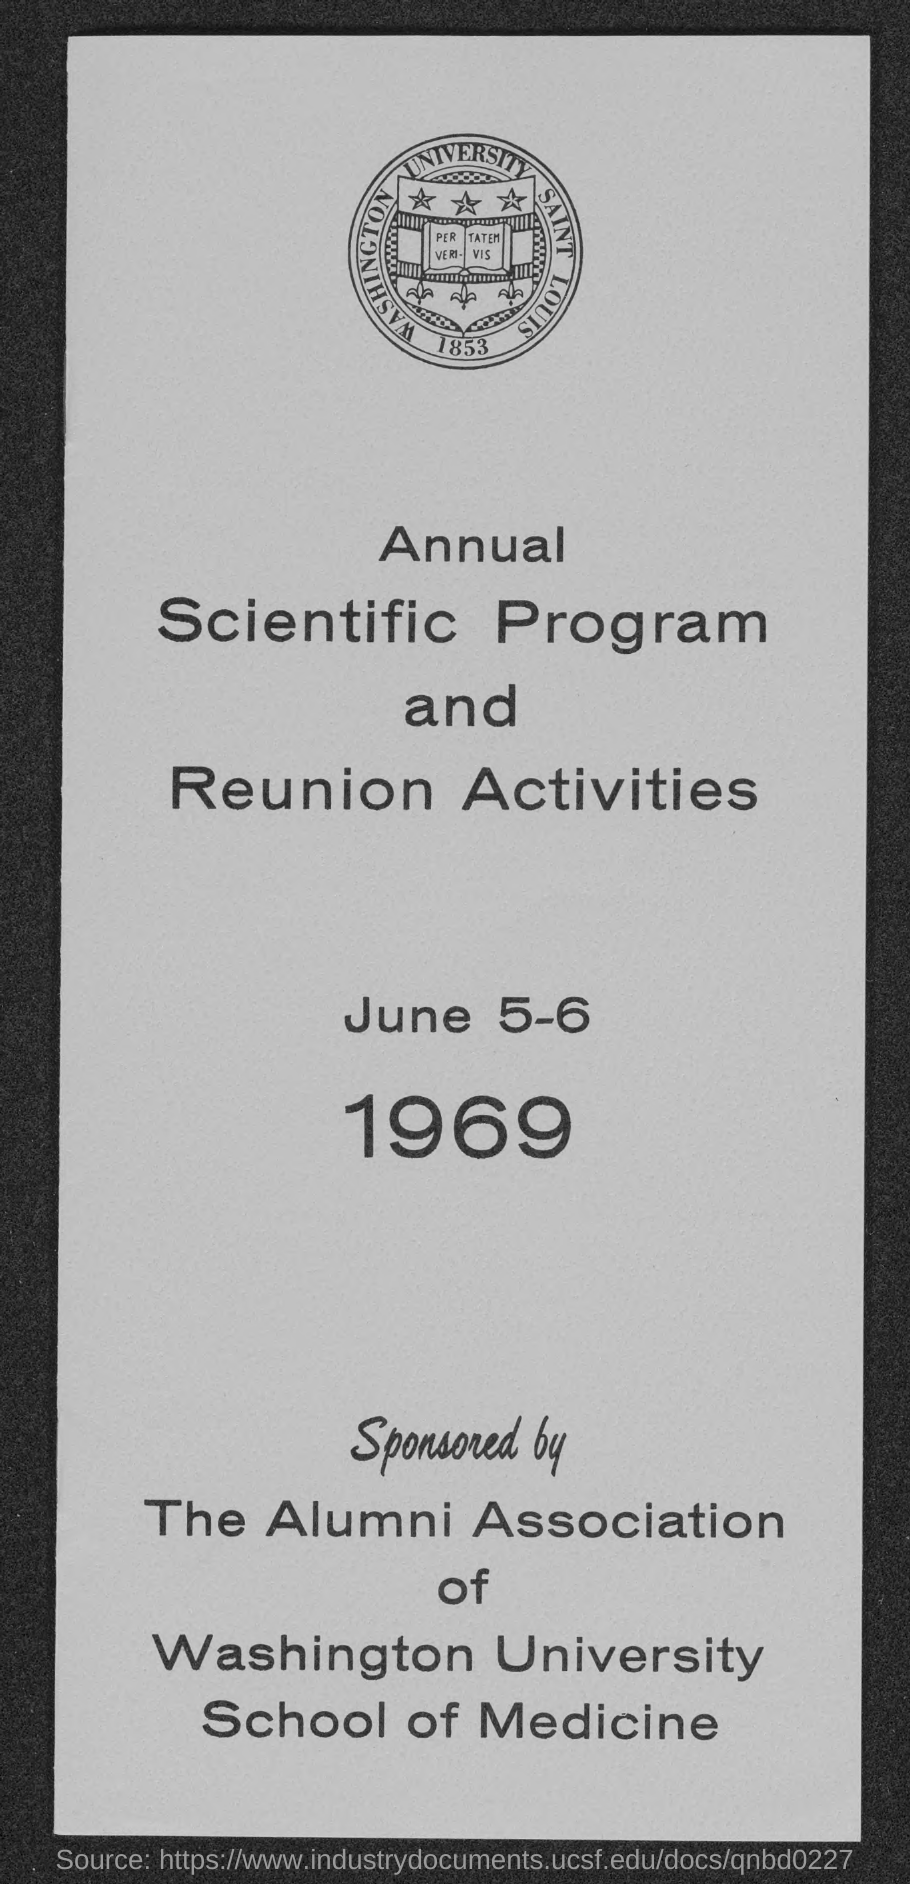Indicate a few pertinent items in this graphic. The annual scientific program and reunion activities will take place on June 5-6, 1969. 